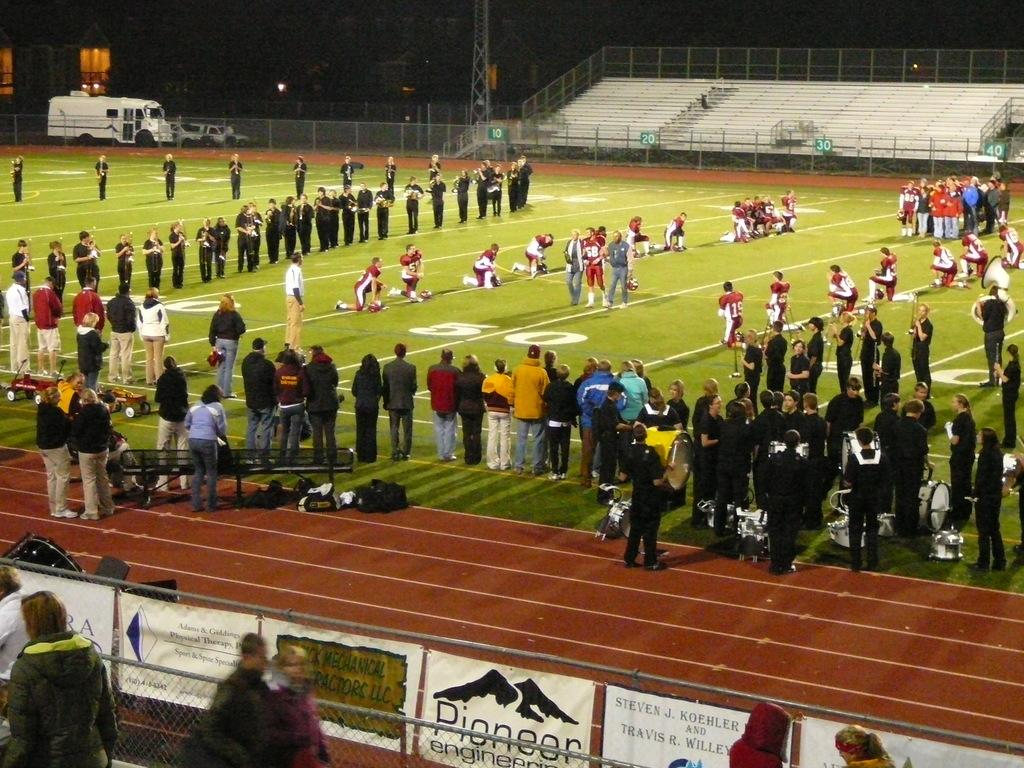What is happening with the group of people in the image? There is a group of people on the ground in the image. What else can be seen in the image besides the people? Vehicles, a fence, banners, and other objects are visible in the image. Can you describe the background of the image? The background of the image is dark. What type of blade is being used by the girls in the image? There are no girls or blades present in the image. Can you see a kite flying in the image? There is no kite visible in the image. 